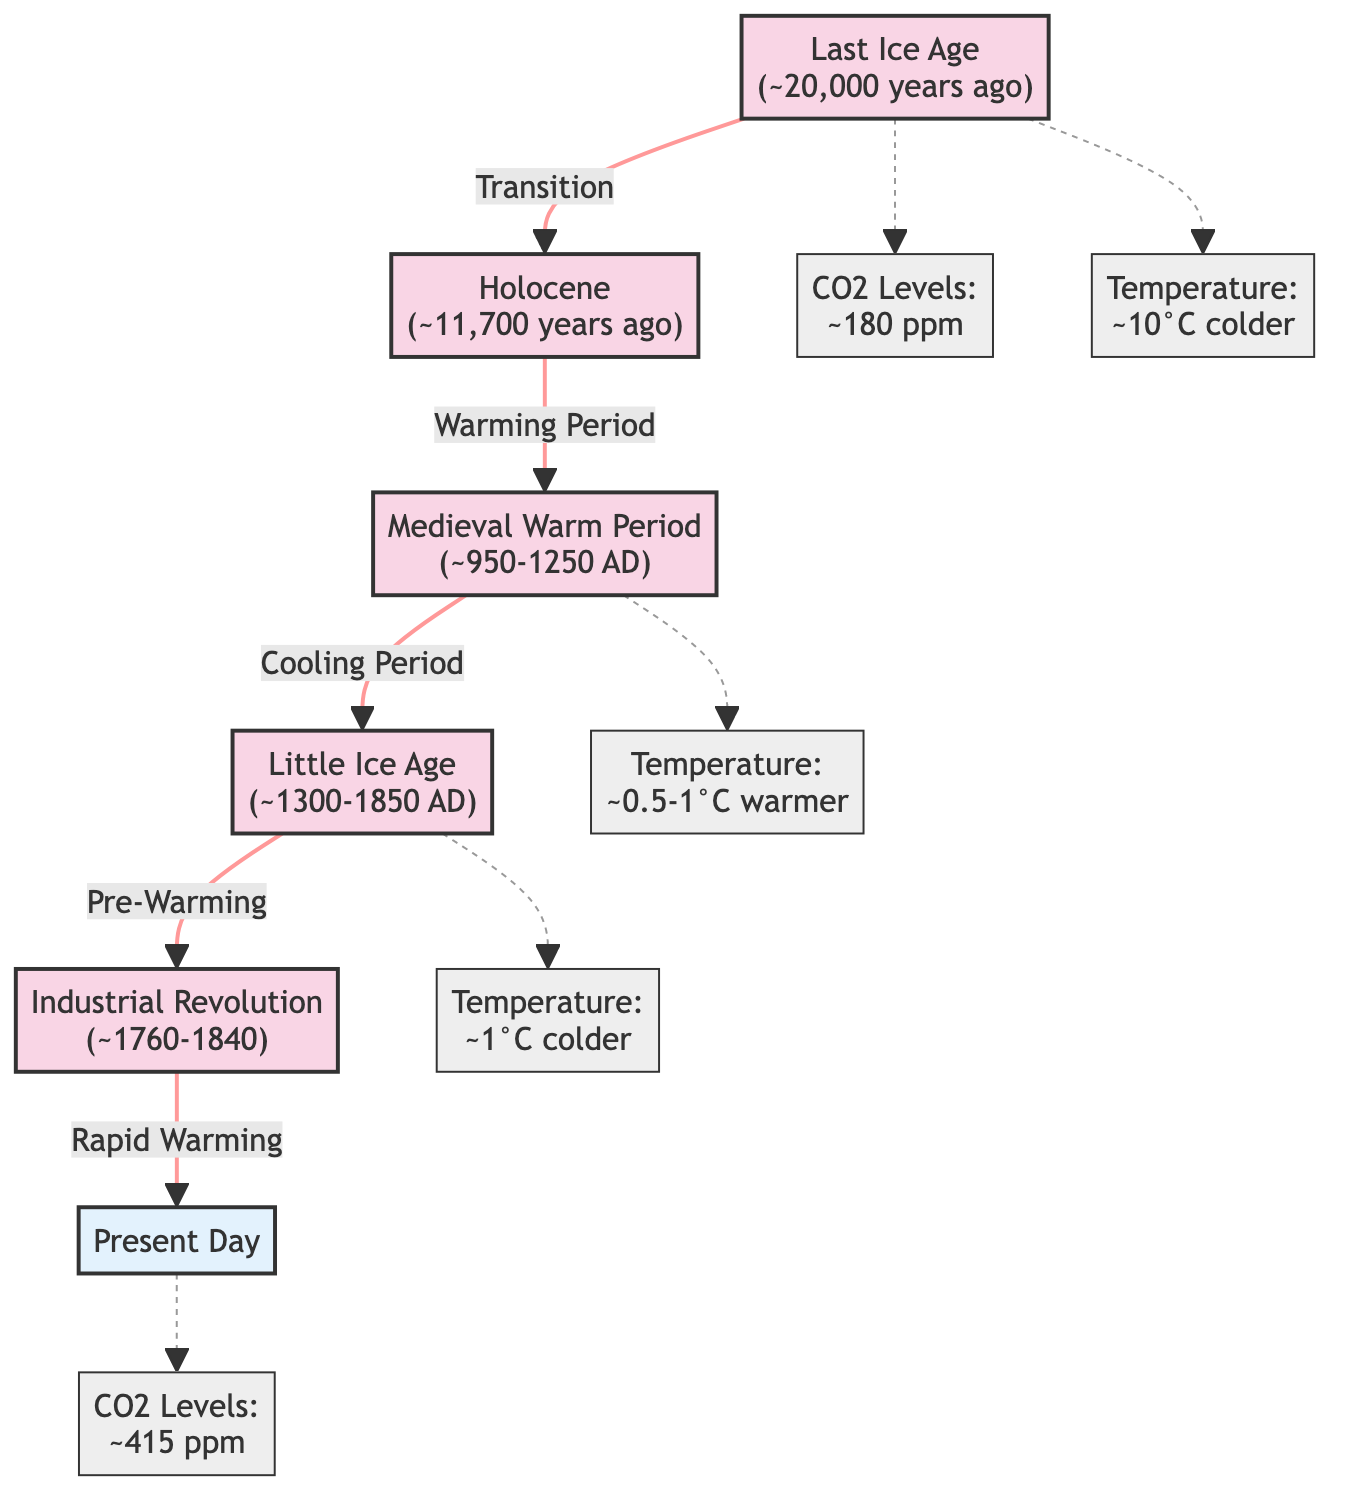What is the temperature during the Little Ice Age? The diagram states that during the Little Ice Age, the temperature was approximately 1°C colder than the current average temperature. This information is directly presented next to the Little Ice Age event node.
Answer: 1°C colder What year does the Holocene period begin? The diagram indicates that the Holocene began around 11,700 years ago. This information is linked directly to the Holocene event node.
Answer: ~11,700 years ago What were the CO2 levels at Present Day? The diagram specifies that the CO2 levels at Present Day are approximately 415 ppm, as indicated next to the Present Day node.
Answer: ~415 ppm Which period follows the Medieval Warm Period? The diagram shows that the period following the Medieval Warm Period is the Little Ice Age, connected by the label "Cooling Period." This can be traced directly from the Medieval Warm Period node to the Little Ice Age node.
Answer: Little Ice Age What is the temperature change from the Last Ice Age to the Medieval Warm Period? The diagram indicates that the temperature was approximately 10°C colder during the Last Ice Age and approximately 0.5-1°C warmer during the Medieval Warm Period. To find the total change, you can calculate 10°C - (-1°C), leading to an approximate change of 10.5-11°C.
Answer: ~10.5-11°C What transitional event connects the Industrial Revolution to Present Day? The diagram indicates that the rapid warming event connects the Industrial Revolution to Present Day. This relationship is explicitly shown by the label connecting these two nodes.
Answer: Rapid Warming How many major climatic events are represented in the diagram? By counting the labeled events in the diagram, we see there are five major climatic events: Last Ice Age, Holocene, Medieval Warm Period, Little Ice Age, and Industrial Revolution. This type of counting involves looking at the individual event nodes.
Answer: 5 What is the CO2 level at the Last Ice Age? The diagram specifies that the CO2 levels during the Last Ice Age were approximately 180 ppm, which is indicated near the Last Ice Age event node.
Answer: ~180 ppm 